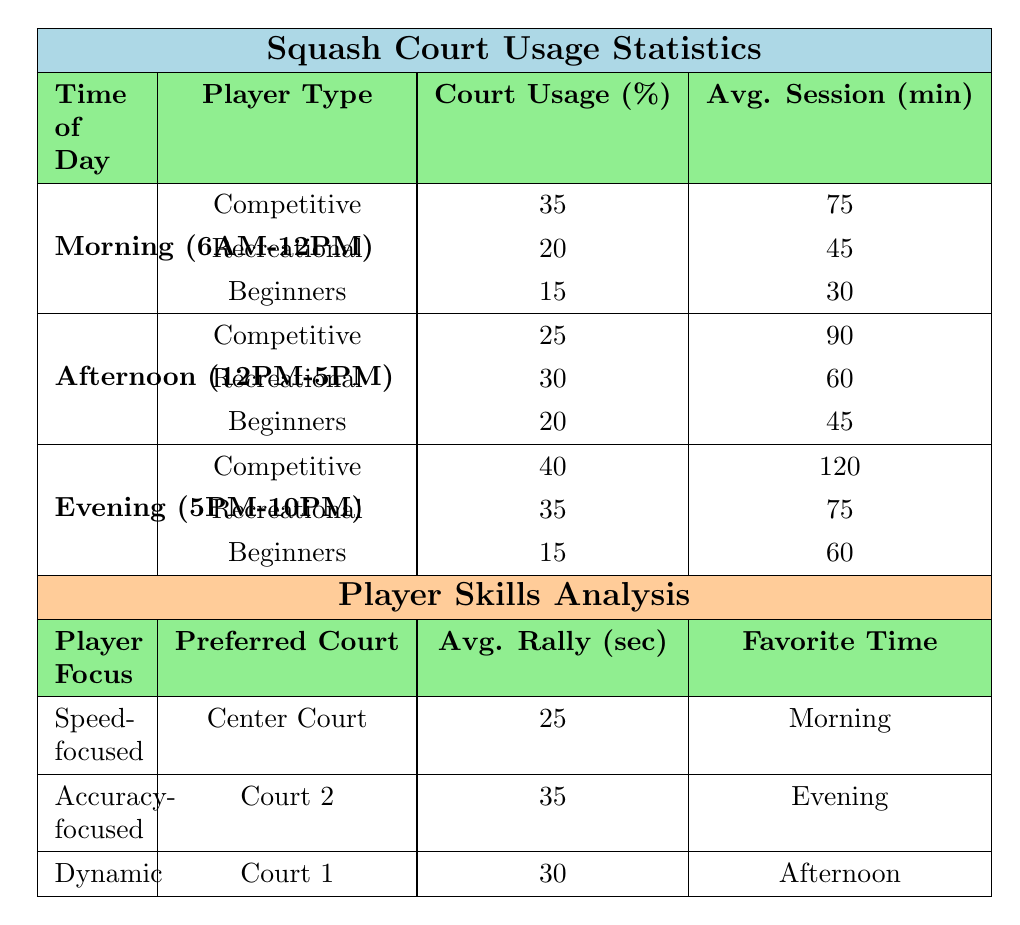What is the most popular court for Competitive players in the Morning? In the Morning time slot, the most popular court for Competitive players is listed as "Center Court."
Answer: Center Court What percentage of Afternoon court usage is attributed to Recreational players? According to the data, Recreational players have a court usage percentage of 30% in the Afternoon.
Answer: 30% What is the average session duration for Beginners in the Evening? The average session duration for Beginners in the Evening is 60 minutes, as stated in the table.
Answer: 60 minutes Which time slot has the highest court usage percentage for Competitive players? The Evening time slot has the highest court usage percentage for Competitive players at 40%.
Answer: Evening How does the Average Session Duration of Competitive players in the Morning compare with that in the Afternoon? In the Morning, the Average Session Duration for Competitive players is 75 minutes, while in the Afternoon, it is 90 minutes. Therefore, the session duration in the Afternoon is longer by 15 minutes.
Answer: 15 minutes longer in the Afternoon What is the average court usage percentage for Beginners across all time slots? To find the average, sum the court usage percentages for Beginners in each time slot: 15% (Morning) + 20% (Afternoon) + 15% (Evening) = 50%. Then divide by the number of time slots (3): 50% / 3 = 16.67%.
Answer: 16.67% Is it true that Recreational players have the longest average session duration in the Morning? In the Morning, Recreational players have an average session duration of 45 minutes, which is shorter than the average session duration for Competitive players at 75 minutes. Therefore, the statement is false.
Answer: No Which player type uses the most time in the Evening, and what is the usage percentage? In the Evening, Competitive players have the highest court usage at 40%.
Answer: Competitive players, 40% Which court is preferred by Dynamic players for training? Dynamic players prefer Court 1 for their training sessions.
Answer: Court 1 How does the average rally length for Speed-focused players compare to that of Accuracy-focused players? Speed-focused players have an average rally length of 25 seconds, while Accuracy-focused players have 35 seconds. The accuracy-focused players' rallies are 10 seconds longer on average.
Answer: 10 seconds longer for Accuracy-focused players What is the most popular court for Beginners during the Afternoon? In the Afternoon, the most popular court for Beginners is Court 5.
Answer: Court 5 